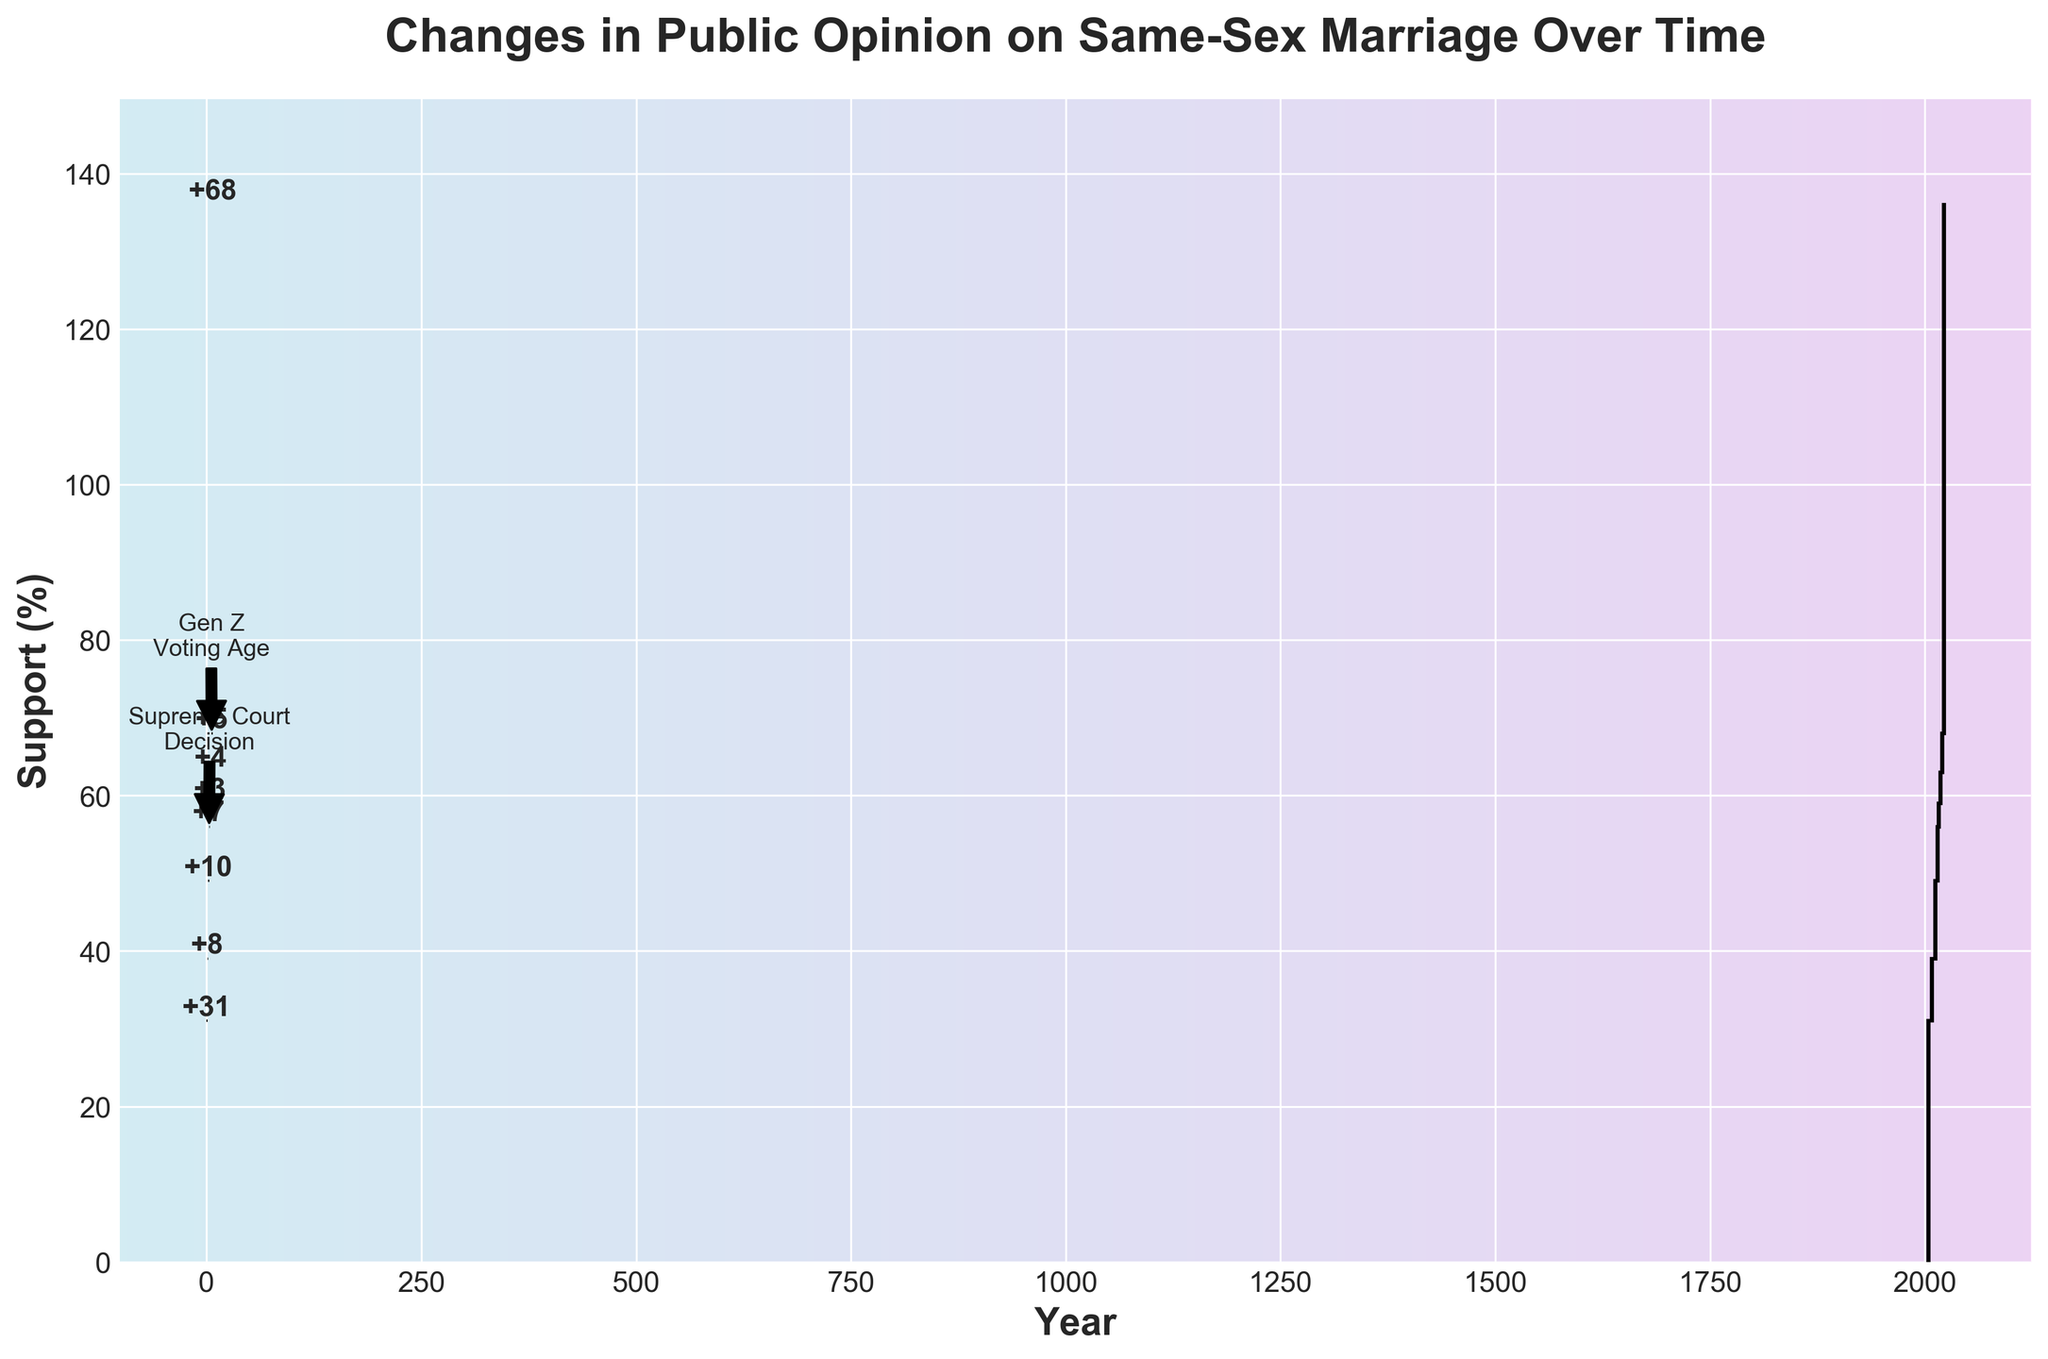What's the title of the chart? The title of the chart is located at the top and reads 'Changes in Public Opinion on Same-Sex Marriage Over Time'.
Answer: Changes in Public Opinion on Same-Sex Marriage Over Time What is the support percentage for same-sex marriage in 2022? The percentage for the year 2022 is labeled on the bar with 'Current Support' and shows a final value at the top.
Answer: 68% How many major increases in support are shown between 2008 and 2020? By counting the bars labeled with 'Increase' between 2008 and 2020, we see increases in 2008, 2012, 2016, 2018, and 2020.
Answer: 5 What was the change in public opinion in the year the Supreme Court decision was made? The bar for 2015 is labeled 'Supreme Court Decision', and the value at the top of the bar indicates the change.
Answer: +7% Compare the support percentage from 2004 to 2015. Was there a net increase or decrease, and by how much? In 2004, the starting value was 31%, and by 2015, we need to look at the cumulative effect before moving to 2016. Summing the changes from 2008 (+8), 2012 (+10), and 2015 (+7) while starting at 31%, results in 31 + 8 + 10 + 7 = 56%.
Answer: Net increase of 25% What is the cumulative change in support from 2004 to 2020? Starting from 2004, add all the changes up to 2020 (31 + 8 + 10 + 7 + 3 + 4 + 5).
Answer: +68 In which year did reaching the Gen Z voting age mark a significant change? We can identify the year labeled with 'Gen Z Voting Age', which marks the year 2020.
Answer: 2020 How does the change in support in 2018 compare to that in 2016? Comparing the values labeled for 2018 (+4) and 2016 (+3), it is clear that 2018 saw a larger increase.
Answer: 2018 had a greater increase What is the difference in support percentage from the start in 2004 to 2008? The starting value in 2004 was 31%. By 2008, we add the change labeled for 2008: 31 + 8 = 39%. So, the difference is 39 - 31.
Answer: +8% What was the overall percentage increase from the starting point in 2004 to the current support in 2022? Starting at 31% in 2004 and finishing at 68% in 2022, the increase can be calculated as 68 - 31.
Answer: +37% 